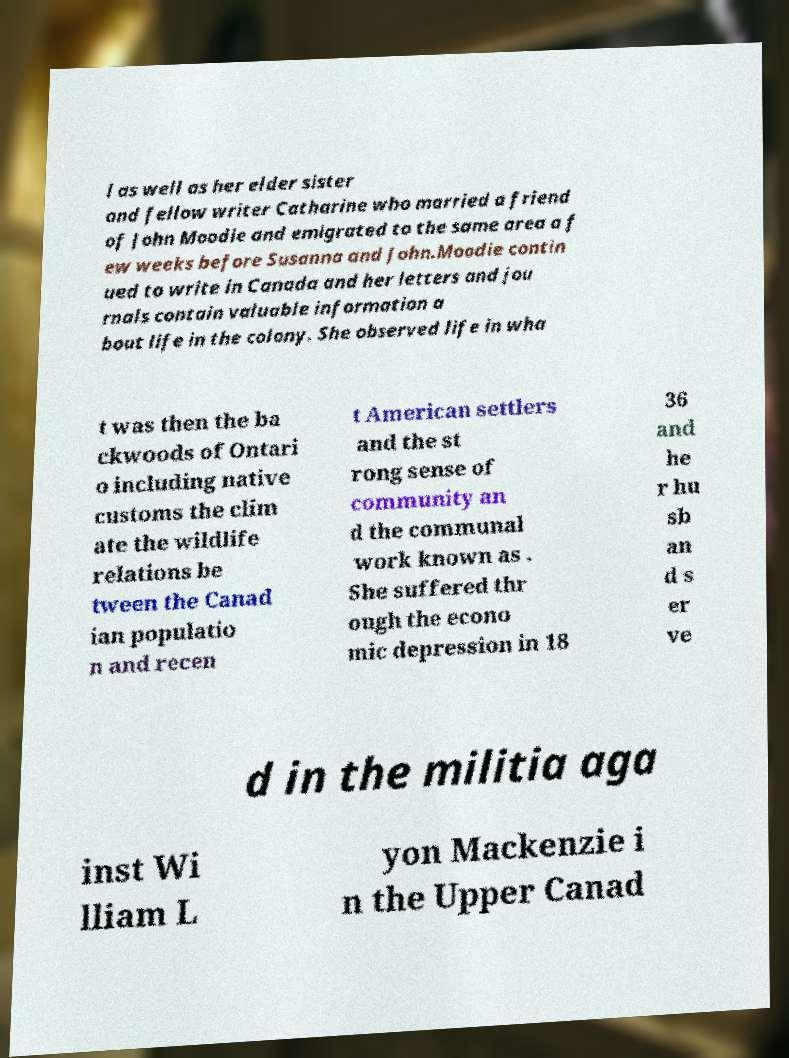Please read and relay the text visible in this image. What does it say? l as well as her elder sister and fellow writer Catharine who married a friend of John Moodie and emigrated to the same area a f ew weeks before Susanna and John.Moodie contin ued to write in Canada and her letters and jou rnals contain valuable information a bout life in the colony. She observed life in wha t was then the ba ckwoods of Ontari o including native customs the clim ate the wildlife relations be tween the Canad ian populatio n and recen t American settlers and the st rong sense of community an d the communal work known as . She suffered thr ough the econo mic depression in 18 36 and he r hu sb an d s er ve d in the militia aga inst Wi lliam L yon Mackenzie i n the Upper Canad 